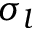Convert formula to latex. <formula><loc_0><loc_0><loc_500><loc_500>\sigma _ { l }</formula> 